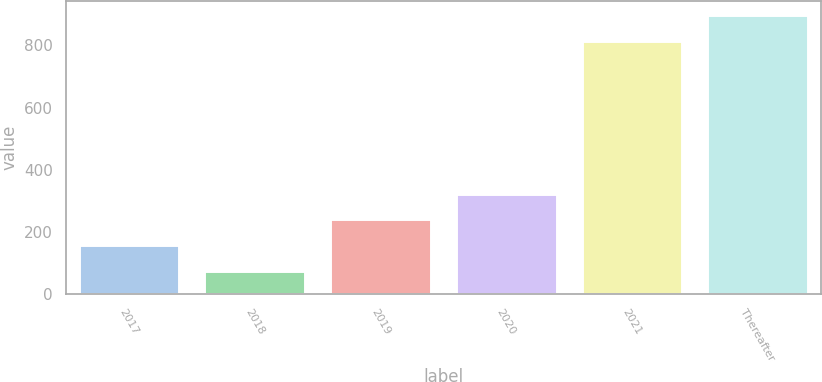Convert chart. <chart><loc_0><loc_0><loc_500><loc_500><bar_chart><fcel>2017<fcel>2018<fcel>2019<fcel>2020<fcel>2021<fcel>Thereafter<nl><fcel>157.77<fcel>75.4<fcel>240.14<fcel>322.51<fcel>814.1<fcel>899.1<nl></chart> 